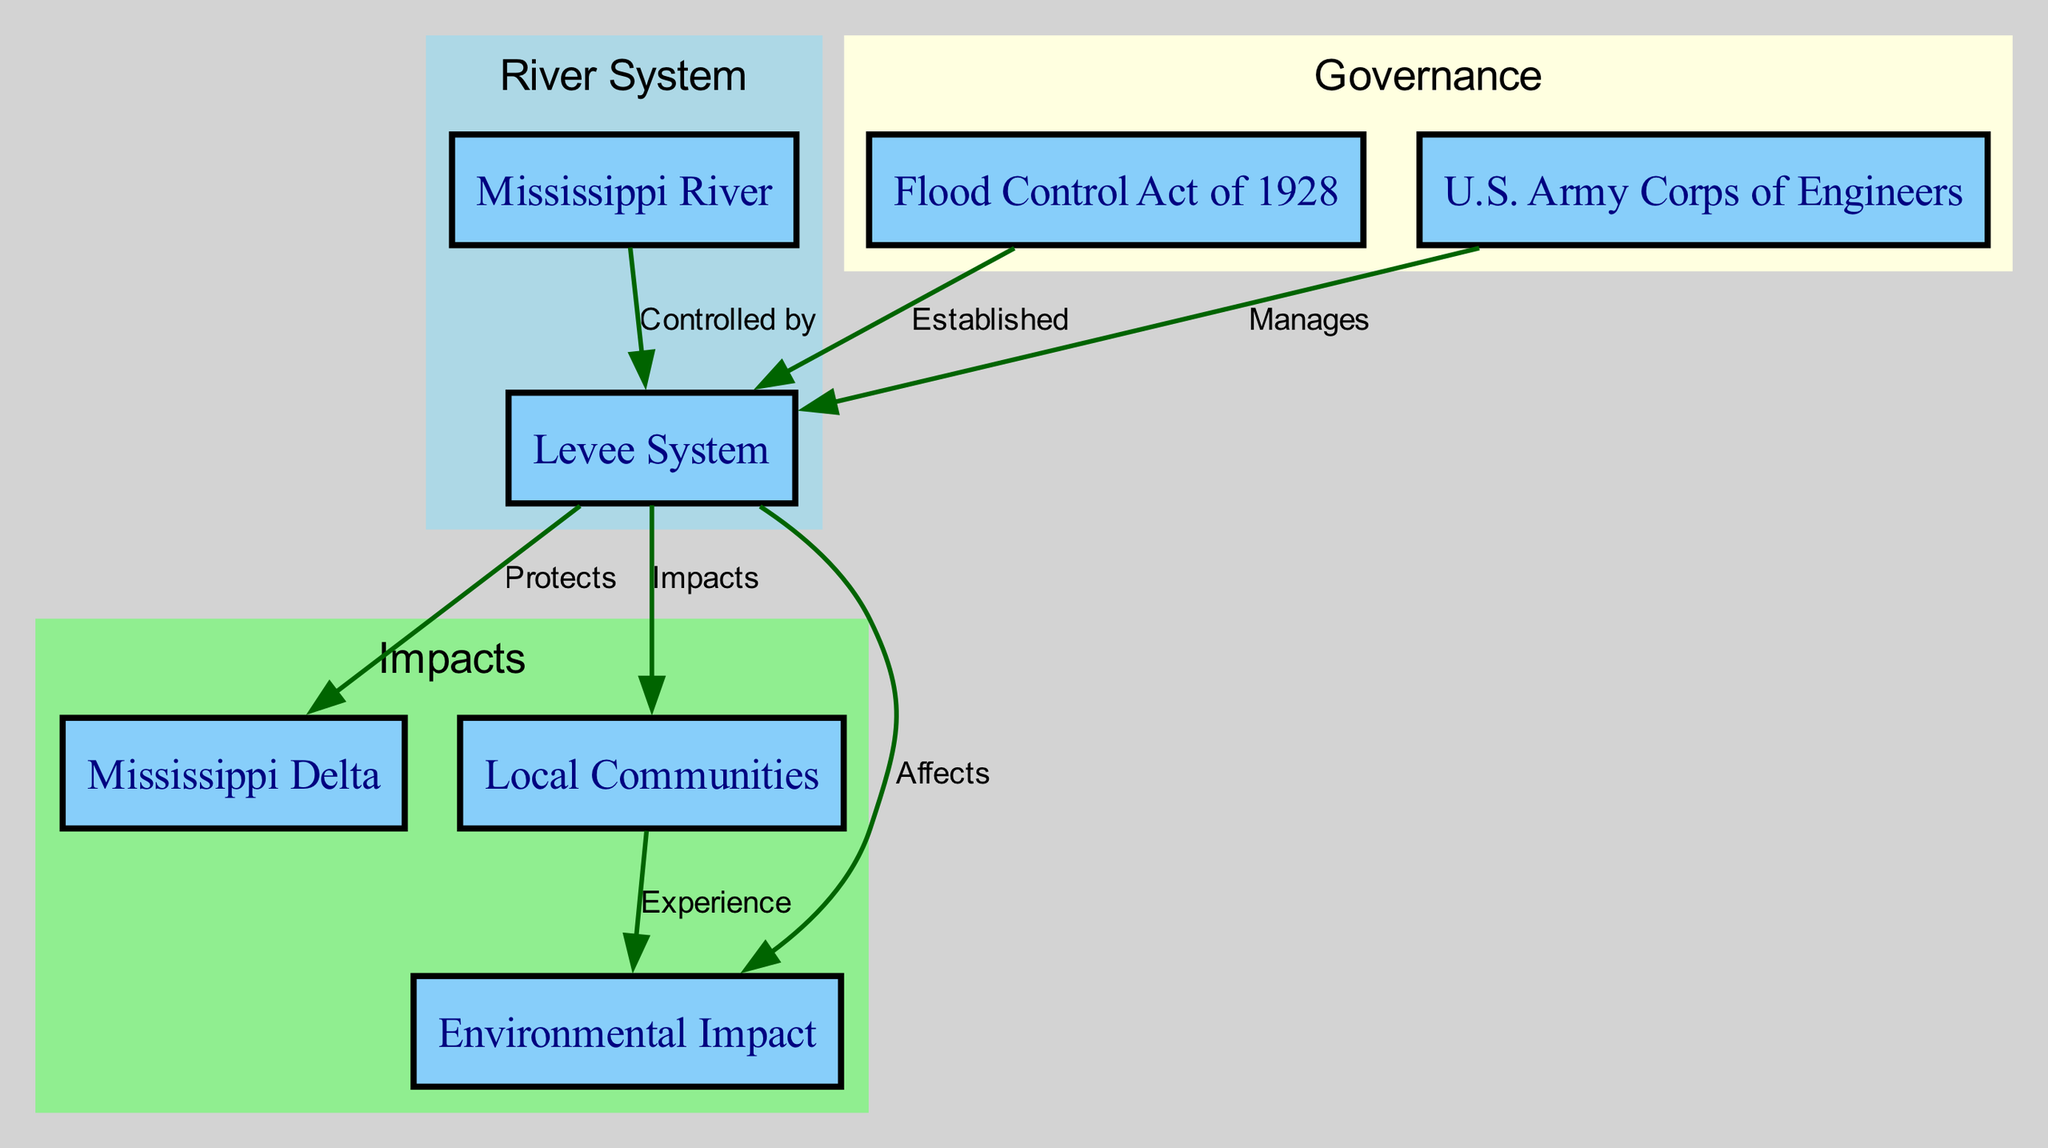What does the levee system protect? The diagram shows that the levee system protects the Mississippi Delta, as indicated by the edge connecting node 2 (Levee System) to node 5 (Mississippi Delta) with the label "Protects."
Answer: Mississippi Delta Who manages the levee system? The diagram indicates that the U.S. Army Corps of Engineers, represented by node 4, manages the levee system, shown by the directed edge from node 4 to node 2 labeled "Manages."
Answer: U.S. Army Corps of Engineers How many nodes are there in the diagram? Counting the nodes presented in the diagram, there are a total of seven distinct nodes, as listed in the data provided.
Answer: 7 What act established the levee system? According to the diagram, the Levee System was established by the Flood Control Act of 1928, indicated by the edge from node 3 (Flood Control Act of 1928) to node 2 (Levee System) labeled "Established."
Answer: Flood Control Act of 1928 What is the impact of the levee system on local communities? The diagram illustrates that the levee system impacts local communities, as shown by the edge connecting node 2 (Levee System) to node 6 (Local Communities) with the label "Impacts."
Answer: Local Communities What are the environmental effects of the levee system? The diagram indicates that the levee system affects the environment, shown by the directed edge from node 2 (Levee System) to node 7 (Environmental Impact) labeled "Affects."
Answer: Environmental Impact How do local communities experience environmental impacts according to the diagram? The diagram shows that local communities experience environmental impacts, represented by the edge from node 6 (Local Communities) to node 7 (Environmental Impact) with the label "Experience." This implies a direct relationship.
Answer: Experience Which two nodes are in the "Governance" subgraph? Looking at the subgraphs, the nodes in the "Governance" cluster are the Flood Control Act of 1928 (node 3) and the U.S. Army Corps of Engineers (node 4), as identified in the diagram's clustering options.
Answer: Flood Control Act of 1928 and U.S. Army Corps of Engineers What type of diagram is being represented here? The structure and organization of the information, along with the directed edges and nodes, indicate that this is a directed graph, which is specific to the type of diagram known as a "College Level Diagram."
Answer: Directed graph 